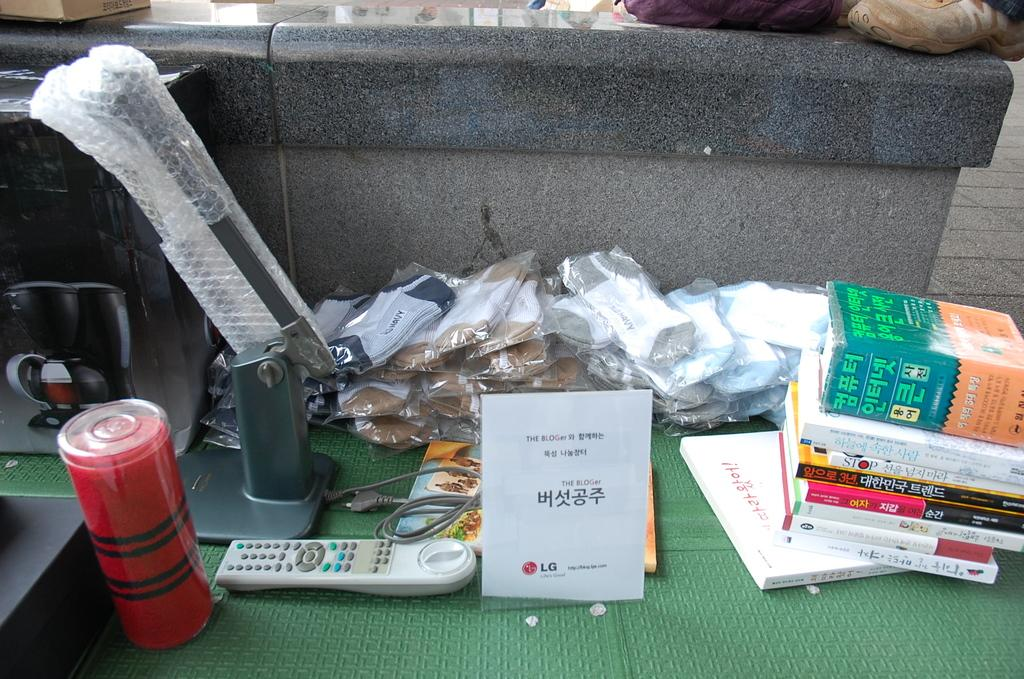Provide a one-sentence caption for the provided image. A miscellaneous of items one being a manual for the BLOGer. 